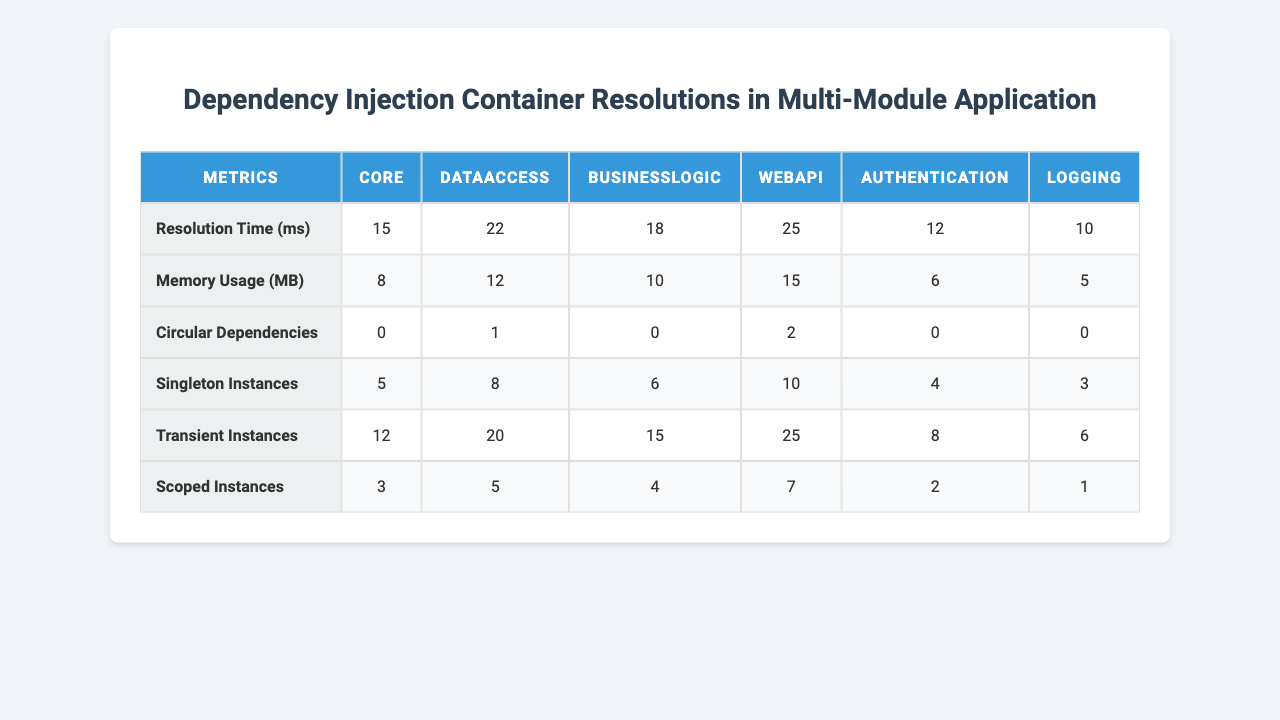What is the resolution time for the WebAPI module? Referring to the table, under the "Resolution Time (ms)" metric for the "WebAPI" module, the value is 25.
Answer: 25 ms How many circular dependencies does the BusinessLogic module have? Looking at the table, the "Circular Dependencies" for the "BusinessLogic" module shows a value of 0.
Answer: 0 Which module has the highest memory usage? By examining the table under "Memory Usage (MB)", the highest value is 15 for the "WebAPI" module.
Answer: WebAPI What is the average resolution time across all modules? The resolutions times are 15, 22, 18, 25, 12, and 10. Summing these gives 102, and dividing by 6 (the number of modules) results in 17.
Answer: 17 ms Do any modules have more than 1 circular dependency? A review of the "Circular Dependencies" row shows that only the "DataAccess" and "WebAPI" modules have circular dependencies, with values of 1 and 2, respectively. Since both have values of 1 or 2, at least one module does.
Answer: Yes Which module has the most scoped instances? In the table, the "Scoped Instances" metric shows that the "WebAPI" module has the highest count with a value of 7.
Answer: WebAPI How does the resolution time of the Core module compare to the Logging module? The Core module has a resolution time of 15 ms while the Logging module has a resolution time of 10 ms. The Core module's resolution time is greater than that of the Logging module by 5 ms.
Answer: Core module is 5 ms longer What is the difference in memory usage between the DataAccess and Authentication modules? The memory usage for DataAccess is 12 MB and for Authentication is 6 MB. The difference is calculated as 12 - 6 = 6 MB.
Answer: 6 MB How many singleton instances are there across all modules combined? By summing the "Singleton Instances" for each module: 5 (Core) + 8 (DataAccess) + 6 (BusinessLogic) + 10 (WebAPI) + 4 (Authentication) + 3 (Logging) = 36 instances in total.
Answer: 36 Is there any module that has no transient instances? Checking the "Transient Instances" values, the only module with a count of 0 is the Logging module.
Answer: Yes, Logging has 0 